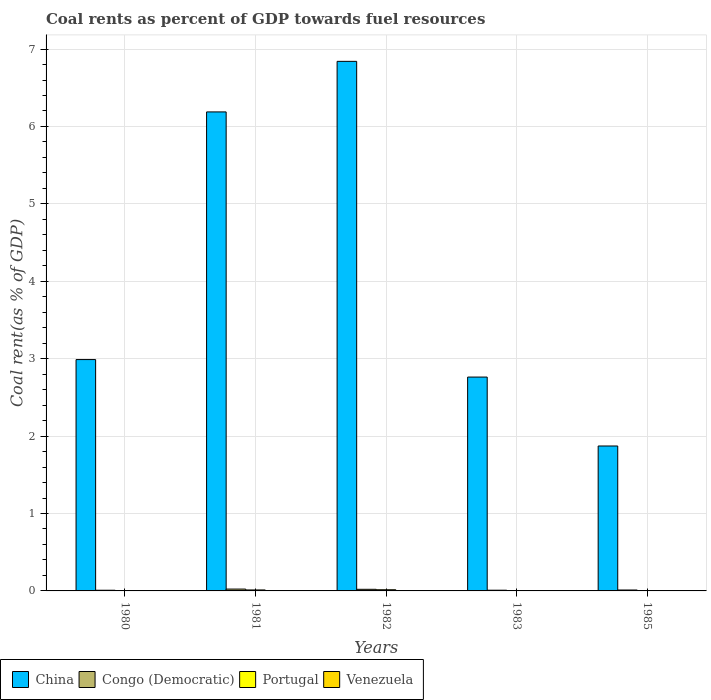How many different coloured bars are there?
Give a very brief answer. 4. Are the number of bars per tick equal to the number of legend labels?
Give a very brief answer. Yes. Are the number of bars on each tick of the X-axis equal?
Offer a terse response. Yes. In how many cases, is the number of bars for a given year not equal to the number of legend labels?
Your response must be concise. 0. What is the coal rent in Portugal in 1981?
Offer a terse response. 0.01. Across all years, what is the maximum coal rent in Portugal?
Your response must be concise. 0.02. Across all years, what is the minimum coal rent in China?
Your answer should be compact. 1.87. In which year was the coal rent in Venezuela minimum?
Your answer should be very brief. 1985. What is the total coal rent in Venezuela in the graph?
Provide a short and direct response. 0. What is the difference between the coal rent in China in 1980 and that in 1981?
Give a very brief answer. -3.2. What is the difference between the coal rent in Portugal in 1985 and the coal rent in Venezuela in 1980?
Provide a short and direct response. 0. What is the average coal rent in China per year?
Make the answer very short. 4.13. In the year 1981, what is the difference between the coal rent in Venezuela and coal rent in Portugal?
Your answer should be compact. -0.01. What is the ratio of the coal rent in Congo (Democratic) in 1981 to that in 1985?
Make the answer very short. 2.03. Is the coal rent in China in 1980 less than that in 1982?
Provide a short and direct response. Yes. What is the difference between the highest and the second highest coal rent in Portugal?
Make the answer very short. 0. What is the difference between the highest and the lowest coal rent in Portugal?
Your response must be concise. 0.01. What does the 3rd bar from the left in 1981 represents?
Ensure brevity in your answer.  Portugal. How many bars are there?
Provide a short and direct response. 20. Are all the bars in the graph horizontal?
Give a very brief answer. No. How many years are there in the graph?
Offer a terse response. 5. Does the graph contain grids?
Your answer should be compact. Yes. Where does the legend appear in the graph?
Your answer should be compact. Bottom left. What is the title of the graph?
Ensure brevity in your answer.  Coal rents as percent of GDP towards fuel resources. What is the label or title of the Y-axis?
Provide a short and direct response. Coal rent(as % of GDP). What is the Coal rent(as % of GDP) in China in 1980?
Offer a terse response. 2.99. What is the Coal rent(as % of GDP) in Congo (Democratic) in 1980?
Keep it short and to the point. 0.01. What is the Coal rent(as % of GDP) in Portugal in 1980?
Your response must be concise. 0. What is the Coal rent(as % of GDP) of Venezuela in 1980?
Give a very brief answer. 0. What is the Coal rent(as % of GDP) of China in 1981?
Make the answer very short. 6.19. What is the Coal rent(as % of GDP) in Congo (Democratic) in 1981?
Provide a succinct answer. 0.02. What is the Coal rent(as % of GDP) of Portugal in 1981?
Provide a succinct answer. 0.01. What is the Coal rent(as % of GDP) in Venezuela in 1981?
Keep it short and to the point. 0. What is the Coal rent(as % of GDP) in China in 1982?
Your answer should be very brief. 6.84. What is the Coal rent(as % of GDP) of Congo (Democratic) in 1982?
Keep it short and to the point. 0.02. What is the Coal rent(as % of GDP) of Portugal in 1982?
Provide a short and direct response. 0.02. What is the Coal rent(as % of GDP) of Venezuela in 1982?
Offer a very short reply. 0. What is the Coal rent(as % of GDP) in China in 1983?
Give a very brief answer. 2.76. What is the Coal rent(as % of GDP) of Congo (Democratic) in 1983?
Your response must be concise. 0.01. What is the Coal rent(as % of GDP) in Portugal in 1983?
Your answer should be very brief. 0. What is the Coal rent(as % of GDP) of Venezuela in 1983?
Give a very brief answer. 0. What is the Coal rent(as % of GDP) in China in 1985?
Your response must be concise. 1.87. What is the Coal rent(as % of GDP) in Congo (Democratic) in 1985?
Your answer should be very brief. 0.01. What is the Coal rent(as % of GDP) of Portugal in 1985?
Offer a very short reply. 0. What is the Coal rent(as % of GDP) of Venezuela in 1985?
Ensure brevity in your answer.  0. Across all years, what is the maximum Coal rent(as % of GDP) of China?
Your response must be concise. 6.84. Across all years, what is the maximum Coal rent(as % of GDP) in Congo (Democratic)?
Provide a short and direct response. 0.02. Across all years, what is the maximum Coal rent(as % of GDP) of Portugal?
Your answer should be very brief. 0.02. Across all years, what is the maximum Coal rent(as % of GDP) in Venezuela?
Keep it short and to the point. 0. Across all years, what is the minimum Coal rent(as % of GDP) of China?
Give a very brief answer. 1.87. Across all years, what is the minimum Coal rent(as % of GDP) in Congo (Democratic)?
Your answer should be compact. 0.01. Across all years, what is the minimum Coal rent(as % of GDP) in Portugal?
Provide a short and direct response. 0. Across all years, what is the minimum Coal rent(as % of GDP) of Venezuela?
Offer a terse response. 0. What is the total Coal rent(as % of GDP) of China in the graph?
Your response must be concise. 20.65. What is the total Coal rent(as % of GDP) of Congo (Democratic) in the graph?
Make the answer very short. 0.07. What is the total Coal rent(as % of GDP) in Portugal in the graph?
Keep it short and to the point. 0.04. What is the total Coal rent(as % of GDP) in Venezuela in the graph?
Offer a very short reply. 0. What is the difference between the Coal rent(as % of GDP) of China in 1980 and that in 1981?
Provide a succinct answer. -3.2. What is the difference between the Coal rent(as % of GDP) in Congo (Democratic) in 1980 and that in 1981?
Give a very brief answer. -0.02. What is the difference between the Coal rent(as % of GDP) of Portugal in 1980 and that in 1981?
Keep it short and to the point. -0.01. What is the difference between the Coal rent(as % of GDP) in Venezuela in 1980 and that in 1981?
Provide a short and direct response. -0. What is the difference between the Coal rent(as % of GDP) in China in 1980 and that in 1982?
Offer a very short reply. -3.85. What is the difference between the Coal rent(as % of GDP) of Congo (Democratic) in 1980 and that in 1982?
Offer a very short reply. -0.01. What is the difference between the Coal rent(as % of GDP) in Portugal in 1980 and that in 1982?
Your answer should be very brief. -0.01. What is the difference between the Coal rent(as % of GDP) of Venezuela in 1980 and that in 1982?
Keep it short and to the point. -0. What is the difference between the Coal rent(as % of GDP) of China in 1980 and that in 1983?
Keep it short and to the point. 0.23. What is the difference between the Coal rent(as % of GDP) in Congo (Democratic) in 1980 and that in 1983?
Offer a terse response. -0. What is the difference between the Coal rent(as % of GDP) of Portugal in 1980 and that in 1983?
Offer a very short reply. -0. What is the difference between the Coal rent(as % of GDP) of Venezuela in 1980 and that in 1983?
Offer a terse response. 0. What is the difference between the Coal rent(as % of GDP) in China in 1980 and that in 1985?
Your answer should be compact. 1.12. What is the difference between the Coal rent(as % of GDP) of Congo (Democratic) in 1980 and that in 1985?
Your answer should be compact. -0. What is the difference between the Coal rent(as % of GDP) of Portugal in 1980 and that in 1985?
Provide a short and direct response. -0. What is the difference between the Coal rent(as % of GDP) of Venezuela in 1980 and that in 1985?
Offer a terse response. 0. What is the difference between the Coal rent(as % of GDP) in China in 1981 and that in 1982?
Your answer should be very brief. -0.65. What is the difference between the Coal rent(as % of GDP) in Congo (Democratic) in 1981 and that in 1982?
Your response must be concise. 0. What is the difference between the Coal rent(as % of GDP) of Portugal in 1981 and that in 1982?
Offer a terse response. -0. What is the difference between the Coal rent(as % of GDP) in Venezuela in 1981 and that in 1982?
Keep it short and to the point. -0. What is the difference between the Coal rent(as % of GDP) in China in 1981 and that in 1983?
Provide a succinct answer. 3.43. What is the difference between the Coal rent(as % of GDP) in Congo (Democratic) in 1981 and that in 1983?
Your answer should be compact. 0.01. What is the difference between the Coal rent(as % of GDP) in Portugal in 1981 and that in 1983?
Provide a succinct answer. 0.01. What is the difference between the Coal rent(as % of GDP) of Venezuela in 1981 and that in 1983?
Ensure brevity in your answer.  0. What is the difference between the Coal rent(as % of GDP) of China in 1981 and that in 1985?
Ensure brevity in your answer.  4.32. What is the difference between the Coal rent(as % of GDP) in Congo (Democratic) in 1981 and that in 1985?
Ensure brevity in your answer.  0.01. What is the difference between the Coal rent(as % of GDP) of Portugal in 1981 and that in 1985?
Offer a terse response. 0.01. What is the difference between the Coal rent(as % of GDP) in Venezuela in 1981 and that in 1985?
Keep it short and to the point. 0. What is the difference between the Coal rent(as % of GDP) of China in 1982 and that in 1983?
Your response must be concise. 4.08. What is the difference between the Coal rent(as % of GDP) in Congo (Democratic) in 1982 and that in 1983?
Make the answer very short. 0.01. What is the difference between the Coal rent(as % of GDP) in Portugal in 1982 and that in 1983?
Keep it short and to the point. 0.01. What is the difference between the Coal rent(as % of GDP) in Venezuela in 1982 and that in 1983?
Offer a very short reply. 0. What is the difference between the Coal rent(as % of GDP) in China in 1982 and that in 1985?
Make the answer very short. 4.97. What is the difference between the Coal rent(as % of GDP) of Congo (Democratic) in 1982 and that in 1985?
Make the answer very short. 0.01. What is the difference between the Coal rent(as % of GDP) of Portugal in 1982 and that in 1985?
Ensure brevity in your answer.  0.01. What is the difference between the Coal rent(as % of GDP) in Venezuela in 1982 and that in 1985?
Offer a terse response. 0. What is the difference between the Coal rent(as % of GDP) of China in 1983 and that in 1985?
Provide a succinct answer. 0.89. What is the difference between the Coal rent(as % of GDP) of Congo (Democratic) in 1983 and that in 1985?
Offer a very short reply. -0. What is the difference between the Coal rent(as % of GDP) of Portugal in 1983 and that in 1985?
Provide a short and direct response. 0. What is the difference between the Coal rent(as % of GDP) in China in 1980 and the Coal rent(as % of GDP) in Congo (Democratic) in 1981?
Make the answer very short. 2.96. What is the difference between the Coal rent(as % of GDP) of China in 1980 and the Coal rent(as % of GDP) of Portugal in 1981?
Make the answer very short. 2.98. What is the difference between the Coal rent(as % of GDP) in China in 1980 and the Coal rent(as % of GDP) in Venezuela in 1981?
Offer a terse response. 2.99. What is the difference between the Coal rent(as % of GDP) in Congo (Democratic) in 1980 and the Coal rent(as % of GDP) in Portugal in 1981?
Make the answer very short. -0. What is the difference between the Coal rent(as % of GDP) of Congo (Democratic) in 1980 and the Coal rent(as % of GDP) of Venezuela in 1981?
Keep it short and to the point. 0.01. What is the difference between the Coal rent(as % of GDP) in Portugal in 1980 and the Coal rent(as % of GDP) in Venezuela in 1981?
Your response must be concise. 0. What is the difference between the Coal rent(as % of GDP) in China in 1980 and the Coal rent(as % of GDP) in Congo (Democratic) in 1982?
Give a very brief answer. 2.97. What is the difference between the Coal rent(as % of GDP) of China in 1980 and the Coal rent(as % of GDP) of Portugal in 1982?
Offer a very short reply. 2.97. What is the difference between the Coal rent(as % of GDP) of China in 1980 and the Coal rent(as % of GDP) of Venezuela in 1982?
Offer a very short reply. 2.99. What is the difference between the Coal rent(as % of GDP) in Congo (Democratic) in 1980 and the Coal rent(as % of GDP) in Portugal in 1982?
Provide a short and direct response. -0.01. What is the difference between the Coal rent(as % of GDP) in Congo (Democratic) in 1980 and the Coal rent(as % of GDP) in Venezuela in 1982?
Your answer should be very brief. 0.01. What is the difference between the Coal rent(as % of GDP) in Portugal in 1980 and the Coal rent(as % of GDP) in Venezuela in 1982?
Your response must be concise. 0. What is the difference between the Coal rent(as % of GDP) in China in 1980 and the Coal rent(as % of GDP) in Congo (Democratic) in 1983?
Keep it short and to the point. 2.98. What is the difference between the Coal rent(as % of GDP) in China in 1980 and the Coal rent(as % of GDP) in Portugal in 1983?
Keep it short and to the point. 2.98. What is the difference between the Coal rent(as % of GDP) in China in 1980 and the Coal rent(as % of GDP) in Venezuela in 1983?
Give a very brief answer. 2.99. What is the difference between the Coal rent(as % of GDP) in Congo (Democratic) in 1980 and the Coal rent(as % of GDP) in Portugal in 1983?
Your answer should be compact. 0. What is the difference between the Coal rent(as % of GDP) in Congo (Democratic) in 1980 and the Coal rent(as % of GDP) in Venezuela in 1983?
Ensure brevity in your answer.  0.01. What is the difference between the Coal rent(as % of GDP) of Portugal in 1980 and the Coal rent(as % of GDP) of Venezuela in 1983?
Offer a very short reply. 0. What is the difference between the Coal rent(as % of GDP) in China in 1980 and the Coal rent(as % of GDP) in Congo (Democratic) in 1985?
Give a very brief answer. 2.98. What is the difference between the Coal rent(as % of GDP) of China in 1980 and the Coal rent(as % of GDP) of Portugal in 1985?
Provide a short and direct response. 2.98. What is the difference between the Coal rent(as % of GDP) of China in 1980 and the Coal rent(as % of GDP) of Venezuela in 1985?
Offer a very short reply. 2.99. What is the difference between the Coal rent(as % of GDP) in Congo (Democratic) in 1980 and the Coal rent(as % of GDP) in Portugal in 1985?
Your answer should be very brief. 0.01. What is the difference between the Coal rent(as % of GDP) of Congo (Democratic) in 1980 and the Coal rent(as % of GDP) of Venezuela in 1985?
Your answer should be compact. 0.01. What is the difference between the Coal rent(as % of GDP) of Portugal in 1980 and the Coal rent(as % of GDP) of Venezuela in 1985?
Keep it short and to the point. 0. What is the difference between the Coal rent(as % of GDP) of China in 1981 and the Coal rent(as % of GDP) of Congo (Democratic) in 1982?
Offer a very short reply. 6.17. What is the difference between the Coal rent(as % of GDP) in China in 1981 and the Coal rent(as % of GDP) in Portugal in 1982?
Make the answer very short. 6.17. What is the difference between the Coal rent(as % of GDP) of China in 1981 and the Coal rent(as % of GDP) of Venezuela in 1982?
Make the answer very short. 6.19. What is the difference between the Coal rent(as % of GDP) of Congo (Democratic) in 1981 and the Coal rent(as % of GDP) of Portugal in 1982?
Give a very brief answer. 0.01. What is the difference between the Coal rent(as % of GDP) of Congo (Democratic) in 1981 and the Coal rent(as % of GDP) of Venezuela in 1982?
Offer a very short reply. 0.02. What is the difference between the Coal rent(as % of GDP) of Portugal in 1981 and the Coal rent(as % of GDP) of Venezuela in 1982?
Keep it short and to the point. 0.01. What is the difference between the Coal rent(as % of GDP) of China in 1981 and the Coal rent(as % of GDP) of Congo (Democratic) in 1983?
Offer a terse response. 6.18. What is the difference between the Coal rent(as % of GDP) of China in 1981 and the Coal rent(as % of GDP) of Portugal in 1983?
Make the answer very short. 6.18. What is the difference between the Coal rent(as % of GDP) in China in 1981 and the Coal rent(as % of GDP) in Venezuela in 1983?
Offer a terse response. 6.19. What is the difference between the Coal rent(as % of GDP) of Congo (Democratic) in 1981 and the Coal rent(as % of GDP) of Portugal in 1983?
Give a very brief answer. 0.02. What is the difference between the Coal rent(as % of GDP) of Congo (Democratic) in 1981 and the Coal rent(as % of GDP) of Venezuela in 1983?
Keep it short and to the point. 0.02. What is the difference between the Coal rent(as % of GDP) of Portugal in 1981 and the Coal rent(as % of GDP) of Venezuela in 1983?
Give a very brief answer. 0.01. What is the difference between the Coal rent(as % of GDP) in China in 1981 and the Coal rent(as % of GDP) in Congo (Democratic) in 1985?
Keep it short and to the point. 6.18. What is the difference between the Coal rent(as % of GDP) in China in 1981 and the Coal rent(as % of GDP) in Portugal in 1985?
Offer a very short reply. 6.18. What is the difference between the Coal rent(as % of GDP) of China in 1981 and the Coal rent(as % of GDP) of Venezuela in 1985?
Keep it short and to the point. 6.19. What is the difference between the Coal rent(as % of GDP) in Congo (Democratic) in 1981 and the Coal rent(as % of GDP) in Portugal in 1985?
Ensure brevity in your answer.  0.02. What is the difference between the Coal rent(as % of GDP) of Congo (Democratic) in 1981 and the Coal rent(as % of GDP) of Venezuela in 1985?
Ensure brevity in your answer.  0.02. What is the difference between the Coal rent(as % of GDP) of Portugal in 1981 and the Coal rent(as % of GDP) of Venezuela in 1985?
Your answer should be compact. 0.01. What is the difference between the Coal rent(as % of GDP) in China in 1982 and the Coal rent(as % of GDP) in Congo (Democratic) in 1983?
Ensure brevity in your answer.  6.83. What is the difference between the Coal rent(as % of GDP) of China in 1982 and the Coal rent(as % of GDP) of Portugal in 1983?
Your response must be concise. 6.84. What is the difference between the Coal rent(as % of GDP) in China in 1982 and the Coal rent(as % of GDP) in Venezuela in 1983?
Your answer should be very brief. 6.84. What is the difference between the Coal rent(as % of GDP) in Congo (Democratic) in 1982 and the Coal rent(as % of GDP) in Portugal in 1983?
Ensure brevity in your answer.  0.02. What is the difference between the Coal rent(as % of GDP) in Congo (Democratic) in 1982 and the Coal rent(as % of GDP) in Venezuela in 1983?
Ensure brevity in your answer.  0.02. What is the difference between the Coal rent(as % of GDP) of Portugal in 1982 and the Coal rent(as % of GDP) of Venezuela in 1983?
Your response must be concise. 0.01. What is the difference between the Coal rent(as % of GDP) in China in 1982 and the Coal rent(as % of GDP) in Congo (Democratic) in 1985?
Your answer should be compact. 6.83. What is the difference between the Coal rent(as % of GDP) in China in 1982 and the Coal rent(as % of GDP) in Portugal in 1985?
Your response must be concise. 6.84. What is the difference between the Coal rent(as % of GDP) in China in 1982 and the Coal rent(as % of GDP) in Venezuela in 1985?
Give a very brief answer. 6.84. What is the difference between the Coal rent(as % of GDP) in Congo (Democratic) in 1982 and the Coal rent(as % of GDP) in Portugal in 1985?
Ensure brevity in your answer.  0.02. What is the difference between the Coal rent(as % of GDP) of Congo (Democratic) in 1982 and the Coal rent(as % of GDP) of Venezuela in 1985?
Provide a short and direct response. 0.02. What is the difference between the Coal rent(as % of GDP) of Portugal in 1982 and the Coal rent(as % of GDP) of Venezuela in 1985?
Make the answer very short. 0.02. What is the difference between the Coal rent(as % of GDP) in China in 1983 and the Coal rent(as % of GDP) in Congo (Democratic) in 1985?
Your response must be concise. 2.75. What is the difference between the Coal rent(as % of GDP) in China in 1983 and the Coal rent(as % of GDP) in Portugal in 1985?
Your answer should be very brief. 2.76. What is the difference between the Coal rent(as % of GDP) of China in 1983 and the Coal rent(as % of GDP) of Venezuela in 1985?
Ensure brevity in your answer.  2.76. What is the difference between the Coal rent(as % of GDP) in Congo (Democratic) in 1983 and the Coal rent(as % of GDP) in Portugal in 1985?
Make the answer very short. 0.01. What is the difference between the Coal rent(as % of GDP) in Congo (Democratic) in 1983 and the Coal rent(as % of GDP) in Venezuela in 1985?
Keep it short and to the point. 0.01. What is the difference between the Coal rent(as % of GDP) in Portugal in 1983 and the Coal rent(as % of GDP) in Venezuela in 1985?
Offer a very short reply. 0. What is the average Coal rent(as % of GDP) of China per year?
Offer a very short reply. 4.13. What is the average Coal rent(as % of GDP) of Congo (Democratic) per year?
Ensure brevity in your answer.  0.01. What is the average Coal rent(as % of GDP) of Portugal per year?
Keep it short and to the point. 0.01. What is the average Coal rent(as % of GDP) of Venezuela per year?
Offer a very short reply. 0. In the year 1980, what is the difference between the Coal rent(as % of GDP) in China and Coal rent(as % of GDP) in Congo (Democratic)?
Offer a very short reply. 2.98. In the year 1980, what is the difference between the Coal rent(as % of GDP) in China and Coal rent(as % of GDP) in Portugal?
Offer a very short reply. 2.99. In the year 1980, what is the difference between the Coal rent(as % of GDP) of China and Coal rent(as % of GDP) of Venezuela?
Offer a very short reply. 2.99. In the year 1980, what is the difference between the Coal rent(as % of GDP) in Congo (Democratic) and Coal rent(as % of GDP) in Portugal?
Give a very brief answer. 0.01. In the year 1980, what is the difference between the Coal rent(as % of GDP) of Congo (Democratic) and Coal rent(as % of GDP) of Venezuela?
Make the answer very short. 0.01. In the year 1980, what is the difference between the Coal rent(as % of GDP) in Portugal and Coal rent(as % of GDP) in Venezuela?
Give a very brief answer. 0. In the year 1981, what is the difference between the Coal rent(as % of GDP) of China and Coal rent(as % of GDP) of Congo (Democratic)?
Offer a terse response. 6.16. In the year 1981, what is the difference between the Coal rent(as % of GDP) in China and Coal rent(as % of GDP) in Portugal?
Offer a terse response. 6.18. In the year 1981, what is the difference between the Coal rent(as % of GDP) of China and Coal rent(as % of GDP) of Venezuela?
Ensure brevity in your answer.  6.19. In the year 1981, what is the difference between the Coal rent(as % of GDP) of Congo (Democratic) and Coal rent(as % of GDP) of Portugal?
Your response must be concise. 0.01. In the year 1981, what is the difference between the Coal rent(as % of GDP) in Congo (Democratic) and Coal rent(as % of GDP) in Venezuela?
Give a very brief answer. 0.02. In the year 1981, what is the difference between the Coal rent(as % of GDP) of Portugal and Coal rent(as % of GDP) of Venezuela?
Keep it short and to the point. 0.01. In the year 1982, what is the difference between the Coal rent(as % of GDP) in China and Coal rent(as % of GDP) in Congo (Democratic)?
Provide a succinct answer. 6.82. In the year 1982, what is the difference between the Coal rent(as % of GDP) in China and Coal rent(as % of GDP) in Portugal?
Offer a very short reply. 6.83. In the year 1982, what is the difference between the Coal rent(as % of GDP) in China and Coal rent(as % of GDP) in Venezuela?
Your response must be concise. 6.84. In the year 1982, what is the difference between the Coal rent(as % of GDP) of Congo (Democratic) and Coal rent(as % of GDP) of Portugal?
Ensure brevity in your answer.  0.01. In the year 1982, what is the difference between the Coal rent(as % of GDP) in Congo (Democratic) and Coal rent(as % of GDP) in Venezuela?
Keep it short and to the point. 0.02. In the year 1982, what is the difference between the Coal rent(as % of GDP) of Portugal and Coal rent(as % of GDP) of Venezuela?
Your response must be concise. 0.01. In the year 1983, what is the difference between the Coal rent(as % of GDP) of China and Coal rent(as % of GDP) of Congo (Democratic)?
Ensure brevity in your answer.  2.75. In the year 1983, what is the difference between the Coal rent(as % of GDP) of China and Coal rent(as % of GDP) of Portugal?
Offer a terse response. 2.76. In the year 1983, what is the difference between the Coal rent(as % of GDP) of China and Coal rent(as % of GDP) of Venezuela?
Keep it short and to the point. 2.76. In the year 1983, what is the difference between the Coal rent(as % of GDP) in Congo (Democratic) and Coal rent(as % of GDP) in Portugal?
Provide a short and direct response. 0. In the year 1983, what is the difference between the Coal rent(as % of GDP) in Congo (Democratic) and Coal rent(as % of GDP) in Venezuela?
Provide a short and direct response. 0.01. In the year 1983, what is the difference between the Coal rent(as % of GDP) in Portugal and Coal rent(as % of GDP) in Venezuela?
Make the answer very short. 0. In the year 1985, what is the difference between the Coal rent(as % of GDP) of China and Coal rent(as % of GDP) of Congo (Democratic)?
Keep it short and to the point. 1.86. In the year 1985, what is the difference between the Coal rent(as % of GDP) in China and Coal rent(as % of GDP) in Portugal?
Provide a short and direct response. 1.87. In the year 1985, what is the difference between the Coal rent(as % of GDP) in China and Coal rent(as % of GDP) in Venezuela?
Keep it short and to the point. 1.87. In the year 1985, what is the difference between the Coal rent(as % of GDP) of Congo (Democratic) and Coal rent(as % of GDP) of Portugal?
Provide a succinct answer. 0.01. In the year 1985, what is the difference between the Coal rent(as % of GDP) of Congo (Democratic) and Coal rent(as % of GDP) of Venezuela?
Keep it short and to the point. 0.01. In the year 1985, what is the difference between the Coal rent(as % of GDP) of Portugal and Coal rent(as % of GDP) of Venezuela?
Offer a terse response. 0. What is the ratio of the Coal rent(as % of GDP) in China in 1980 to that in 1981?
Your response must be concise. 0.48. What is the ratio of the Coal rent(as % of GDP) of Congo (Democratic) in 1980 to that in 1981?
Your answer should be compact. 0.37. What is the ratio of the Coal rent(as % of GDP) of Portugal in 1980 to that in 1981?
Ensure brevity in your answer.  0.22. What is the ratio of the Coal rent(as % of GDP) of Venezuela in 1980 to that in 1981?
Provide a short and direct response. 0.22. What is the ratio of the Coal rent(as % of GDP) of China in 1980 to that in 1982?
Provide a short and direct response. 0.44. What is the ratio of the Coal rent(as % of GDP) of Congo (Democratic) in 1980 to that in 1982?
Provide a succinct answer. 0.42. What is the ratio of the Coal rent(as % of GDP) in Portugal in 1980 to that in 1982?
Make the answer very short. 0.18. What is the ratio of the Coal rent(as % of GDP) of Venezuela in 1980 to that in 1982?
Give a very brief answer. 0.19. What is the ratio of the Coal rent(as % of GDP) in China in 1980 to that in 1983?
Your answer should be compact. 1.08. What is the ratio of the Coal rent(as % of GDP) of Congo (Democratic) in 1980 to that in 1983?
Provide a short and direct response. 0.96. What is the ratio of the Coal rent(as % of GDP) in Portugal in 1980 to that in 1983?
Your answer should be compact. 0.6. What is the ratio of the Coal rent(as % of GDP) of Venezuela in 1980 to that in 1983?
Keep it short and to the point. 1.32. What is the ratio of the Coal rent(as % of GDP) of China in 1980 to that in 1985?
Offer a very short reply. 1.6. What is the ratio of the Coal rent(as % of GDP) of Congo (Democratic) in 1980 to that in 1985?
Keep it short and to the point. 0.75. What is the ratio of the Coal rent(as % of GDP) in Portugal in 1980 to that in 1985?
Offer a very short reply. 0.73. What is the ratio of the Coal rent(as % of GDP) in Venezuela in 1980 to that in 1985?
Make the answer very short. 1.84. What is the ratio of the Coal rent(as % of GDP) in China in 1981 to that in 1982?
Your answer should be compact. 0.9. What is the ratio of the Coal rent(as % of GDP) of Congo (Democratic) in 1981 to that in 1982?
Give a very brief answer. 1.14. What is the ratio of the Coal rent(as % of GDP) of Portugal in 1981 to that in 1982?
Offer a terse response. 0.83. What is the ratio of the Coal rent(as % of GDP) of Venezuela in 1981 to that in 1982?
Give a very brief answer. 0.86. What is the ratio of the Coal rent(as % of GDP) of China in 1981 to that in 1983?
Your answer should be compact. 2.24. What is the ratio of the Coal rent(as % of GDP) in Congo (Democratic) in 1981 to that in 1983?
Give a very brief answer. 2.6. What is the ratio of the Coal rent(as % of GDP) in Portugal in 1981 to that in 1983?
Your answer should be compact. 2.75. What is the ratio of the Coal rent(as % of GDP) of Venezuela in 1981 to that in 1983?
Provide a short and direct response. 6.11. What is the ratio of the Coal rent(as % of GDP) in China in 1981 to that in 1985?
Your answer should be compact. 3.31. What is the ratio of the Coal rent(as % of GDP) of Congo (Democratic) in 1981 to that in 1985?
Give a very brief answer. 2.03. What is the ratio of the Coal rent(as % of GDP) of Portugal in 1981 to that in 1985?
Offer a very short reply. 3.33. What is the ratio of the Coal rent(as % of GDP) of Venezuela in 1981 to that in 1985?
Offer a very short reply. 8.49. What is the ratio of the Coal rent(as % of GDP) in China in 1982 to that in 1983?
Keep it short and to the point. 2.48. What is the ratio of the Coal rent(as % of GDP) in Congo (Democratic) in 1982 to that in 1983?
Ensure brevity in your answer.  2.28. What is the ratio of the Coal rent(as % of GDP) in Portugal in 1982 to that in 1983?
Your answer should be compact. 3.31. What is the ratio of the Coal rent(as % of GDP) of Venezuela in 1982 to that in 1983?
Keep it short and to the point. 7.06. What is the ratio of the Coal rent(as % of GDP) in China in 1982 to that in 1985?
Keep it short and to the point. 3.65. What is the ratio of the Coal rent(as % of GDP) of Congo (Democratic) in 1982 to that in 1985?
Your response must be concise. 1.78. What is the ratio of the Coal rent(as % of GDP) of Portugal in 1982 to that in 1985?
Provide a succinct answer. 4.01. What is the ratio of the Coal rent(as % of GDP) in Venezuela in 1982 to that in 1985?
Provide a succinct answer. 9.81. What is the ratio of the Coal rent(as % of GDP) of China in 1983 to that in 1985?
Offer a very short reply. 1.48. What is the ratio of the Coal rent(as % of GDP) in Congo (Democratic) in 1983 to that in 1985?
Your response must be concise. 0.78. What is the ratio of the Coal rent(as % of GDP) in Portugal in 1983 to that in 1985?
Offer a very short reply. 1.21. What is the ratio of the Coal rent(as % of GDP) of Venezuela in 1983 to that in 1985?
Offer a terse response. 1.39. What is the difference between the highest and the second highest Coal rent(as % of GDP) of China?
Provide a succinct answer. 0.65. What is the difference between the highest and the second highest Coal rent(as % of GDP) in Congo (Democratic)?
Provide a short and direct response. 0. What is the difference between the highest and the second highest Coal rent(as % of GDP) in Portugal?
Provide a short and direct response. 0. What is the difference between the highest and the second highest Coal rent(as % of GDP) in Venezuela?
Keep it short and to the point. 0. What is the difference between the highest and the lowest Coal rent(as % of GDP) in China?
Provide a succinct answer. 4.97. What is the difference between the highest and the lowest Coal rent(as % of GDP) in Congo (Democratic)?
Your answer should be compact. 0.02. What is the difference between the highest and the lowest Coal rent(as % of GDP) in Portugal?
Your answer should be compact. 0.01. What is the difference between the highest and the lowest Coal rent(as % of GDP) of Venezuela?
Give a very brief answer. 0. 